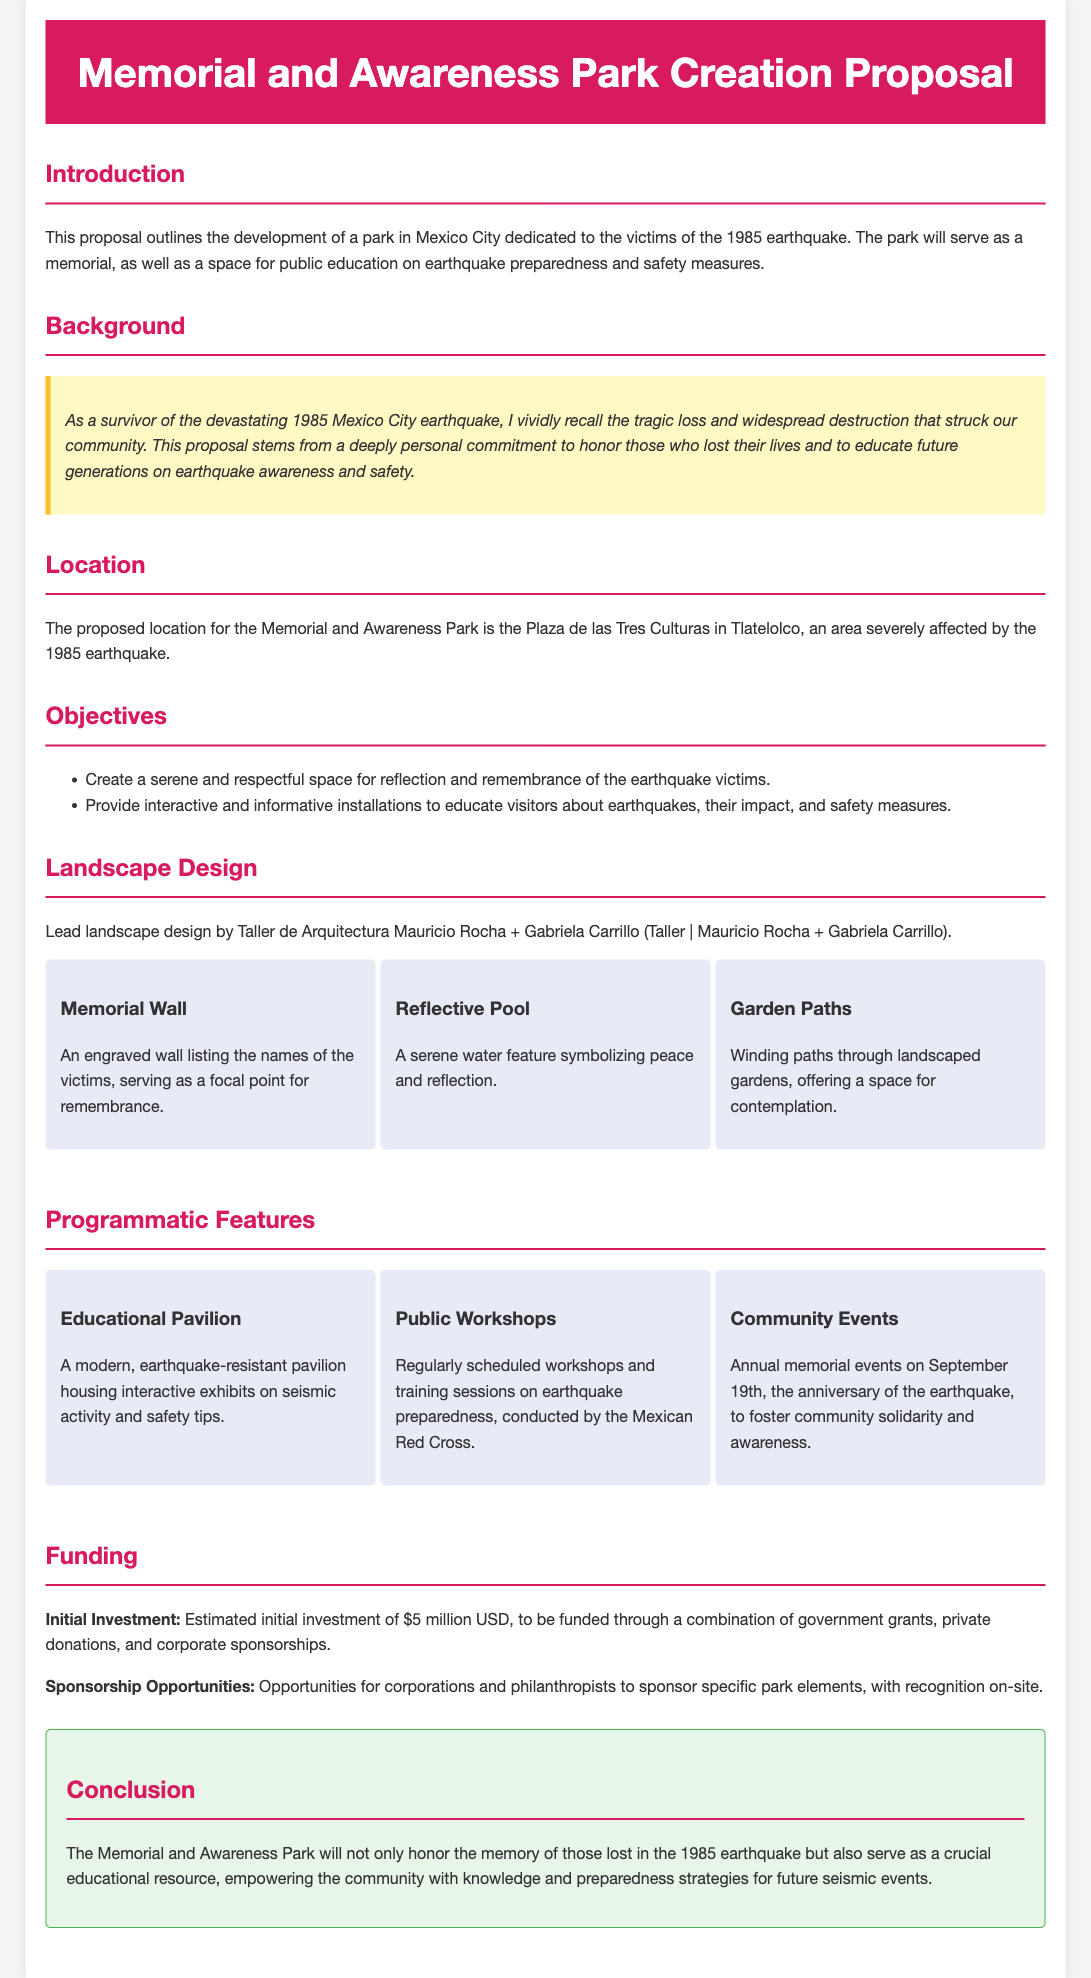What is the title of the proposal? The title is found in the header section of the document.
Answer: Memorial and Awareness Park Creation Proposal Where is the proposed location for the park? The location is specified in the section titled "Location."
Answer: Plaza de las Tres Culturas in Tlatelolco Who is leading the landscape design? The information is provided in the "Landscape Design" section.
Answer: Taller de Arquitectura Mauricio Rocha + Gabriela Carrillo What is the estimated initial investment for the park? The investment figure is mentioned in the "Funding" section.
Answer: $5 million USD What is one of the objectives of the park? Objectives are listed in the "Objectives" section.
Answer: Create a serene and respectful space for reflection and remembrance of the earthquake victims What significant annual event is planned for the park? The event is mentioned in the "Programmatic Features" section.
Answer: Annual memorial events on September 19th What type of educational feature will the park have? This is specified in the "Programmatic Features" section.
Answer: Educational Pavilion Why was this proposal created? The reasoning is provided in the "Background" section.
Answer: To honor those who lost their lives and to educate future generations on earthquake awareness and safety 